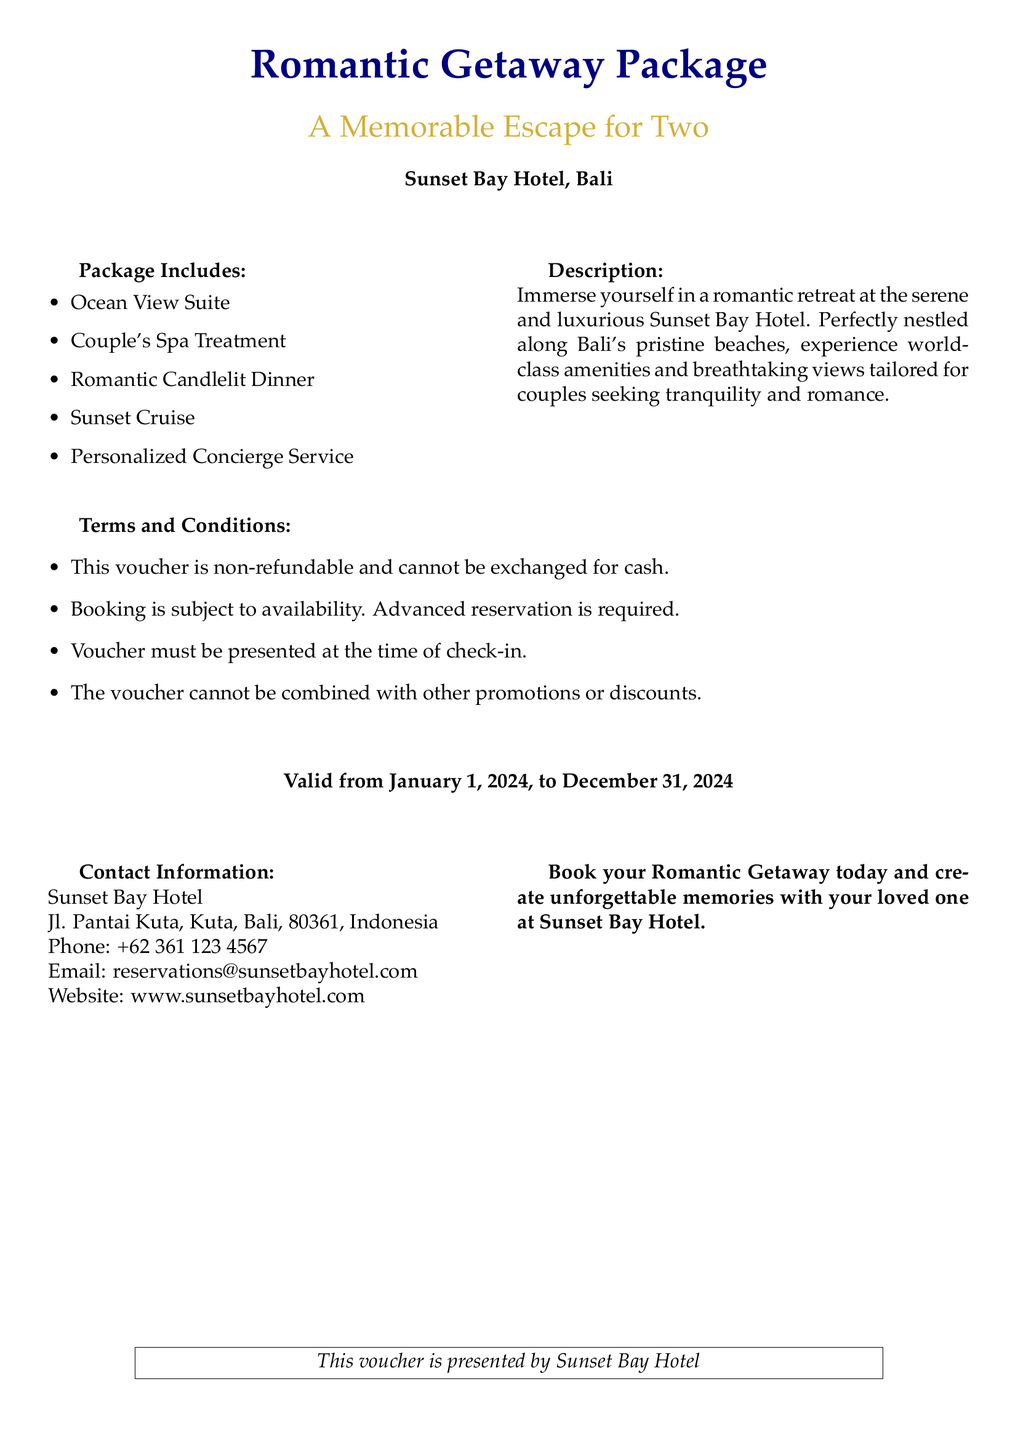What is included in the package? The package includes multiple amenities listed in the document, such as an Ocean View Suite, Couple's Spa Treatment, Romantic Candlelit Dinner, Sunset Cruise, and Personalized Concierge Service.
Answer: Ocean View Suite, Couple's Spa Treatment, Romantic Candlelit Dinner, Sunset Cruise, Personalized Concierge Service What is the name of the hotel? The document provides the name of the hotel where the romantic getaway package is available.
Answer: Sunset Bay Hotel What is the validity period of the voucher? The document specifies the start and end dates for using the voucher.
Answer: January 1, 2024, to December 31, 2024 Is this voucher refundable? The document states the conditions related to the voucher, including information about refunds.
Answer: Non-refundable What type of room is included in the Romantic Getaway Package? The document lists the type of accommodation included in the package.
Answer: Ocean View Suite What kind of dinner is included in the package? The document describes the dining experience provided in the package.
Answer: Romantic Candlelit Dinner What must be presented at check-in? The document highlights a requirement for when guests arrive at the hotel.
Answer: Voucher Can the voucher be combined with other promotions? The document outlines specific terms regarding promotional offers related to the voucher.
Answer: No What is the phone number for reservations? The contact information section of the document states a specific phone number for inquiries.
Answer: +62 361 123 4567 